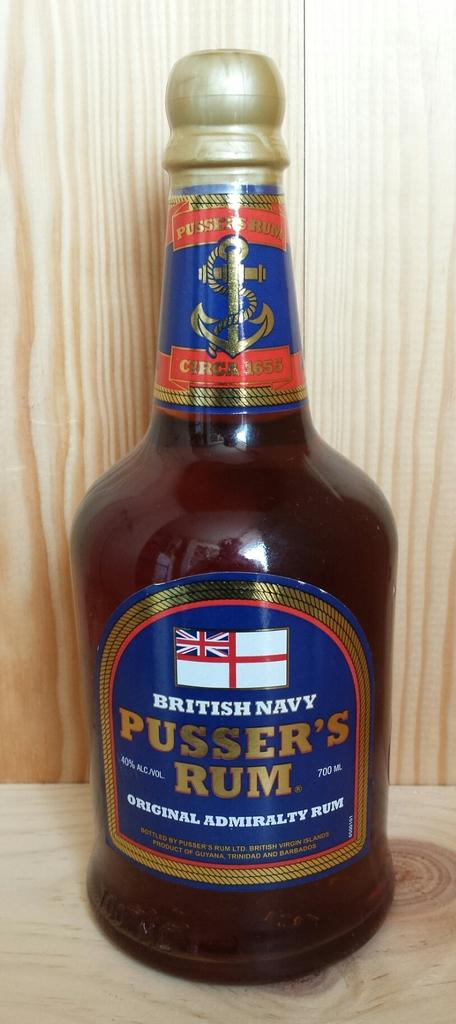Provide a one-sentence caption for the provided image. A brown bottle of British Navy Pusser's Rum. 